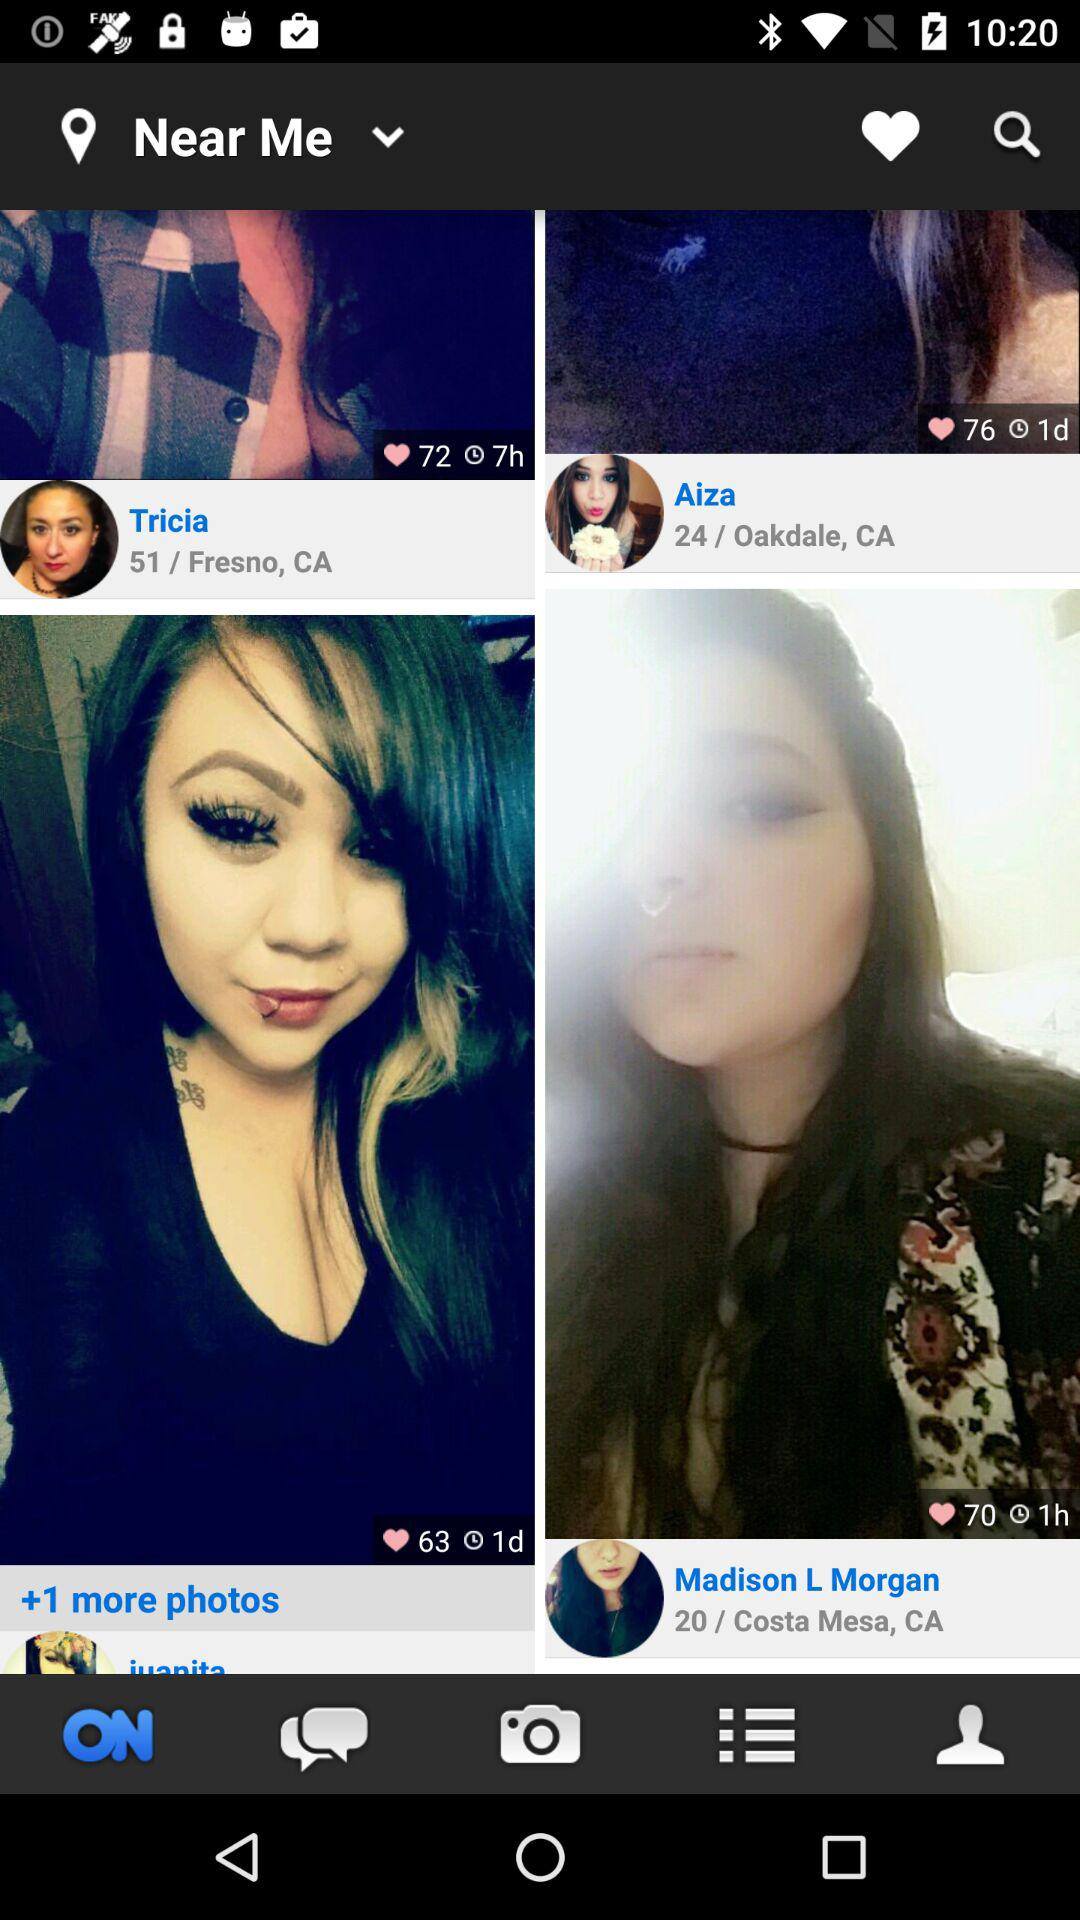What is the time duration of the photo post by Aiza? The time duration of the photo post by Aiza is 1 day. 